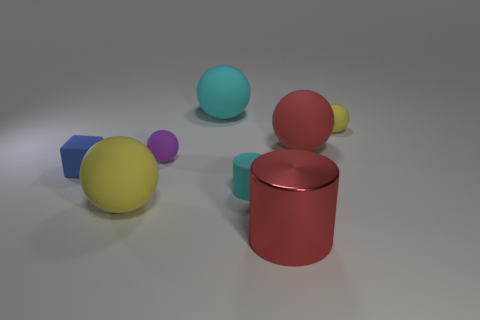What number of things are either yellow matte objects left of the cyan rubber ball or cyan cylinders that are in front of the small yellow rubber object? Upon inspecting the image, we can see that there is one yellow matte ball to the left of the cyan rubber ball. Additionally, there are no cyan cylinders in front of any small yellow rubber objects. Therefore, the total count of items matching the description provided in the question is one. 